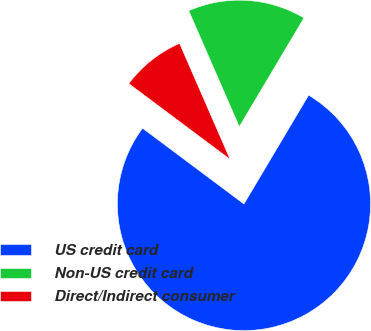<chart> <loc_0><loc_0><loc_500><loc_500><pie_chart><fcel>US credit card<fcel>Non-US credit card<fcel>Direct/Indirect consumer<nl><fcel>76.68%<fcel>15.08%<fcel>8.24%<nl></chart> 